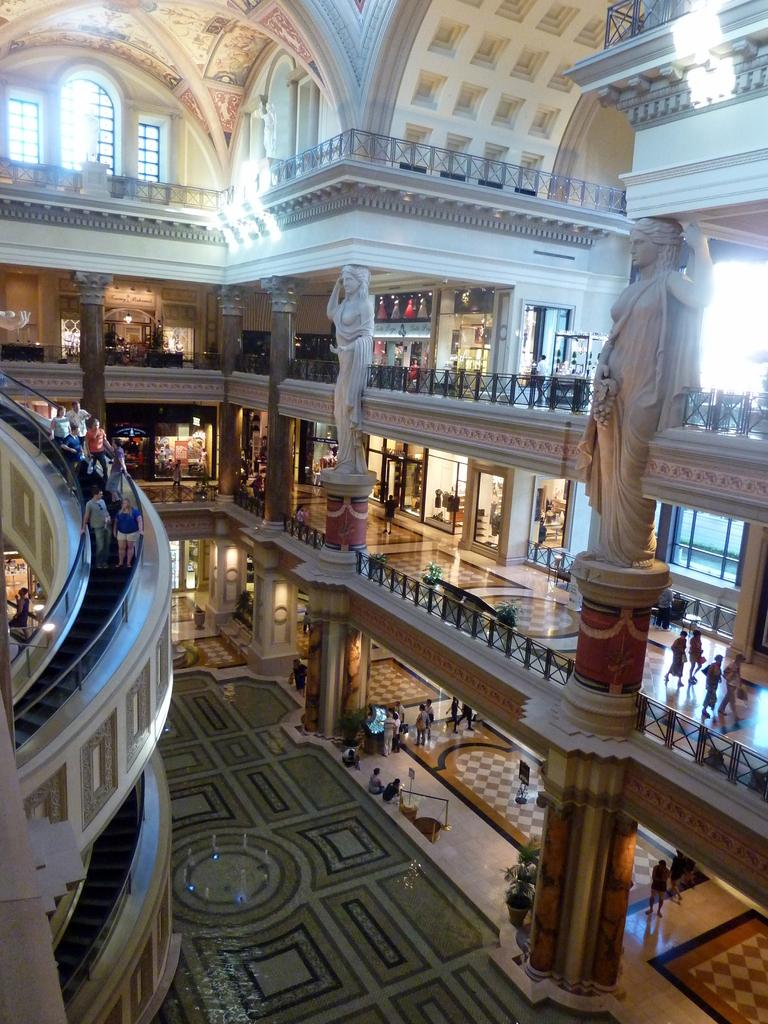What type of location is depicted in the image? The image shows an inside view of a building. Where are the persons located in the image? The persons are on the left side of the image. What are the persons doing in the image? The persons are standing on an escalator. What type of tomatoes can be seen growing on the escalator in the image? There are no tomatoes present in the image, and the escalator is not a suitable environment for growing plants. 